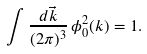Convert formula to latex. <formula><loc_0><loc_0><loc_500><loc_500>\int \frac { d \vec { k } } { ( 2 \pi ) ^ { 3 } } \, \phi ^ { 2 } _ { 0 } ( k ) = 1 .</formula> 